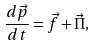<formula> <loc_0><loc_0><loc_500><loc_500>\frac { d \vec { p } } { d t } = \vec { f } + \vec { \Pi } ,</formula> 